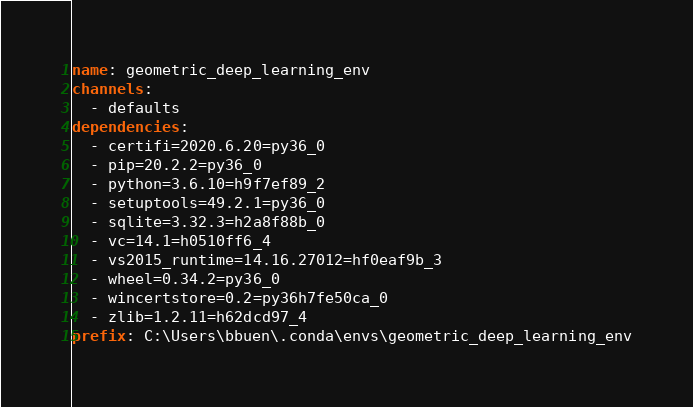Convert code to text. <code><loc_0><loc_0><loc_500><loc_500><_YAML_>name: geometric_deep_learning_env
channels:
  - defaults
dependencies:
  - certifi=2020.6.20=py36_0
  - pip=20.2.2=py36_0
  - python=3.6.10=h9f7ef89_2
  - setuptools=49.2.1=py36_0
  - sqlite=3.32.3=h2a8f88b_0
  - vc=14.1=h0510ff6_4
  - vs2015_runtime=14.16.27012=hf0eaf9b_3
  - wheel=0.34.2=py36_0
  - wincertstore=0.2=py36h7fe50ca_0
  - zlib=1.2.11=h62dcd97_4
prefix: C:\Users\bbuen\.conda\envs\geometric_deep_learning_env

</code> 